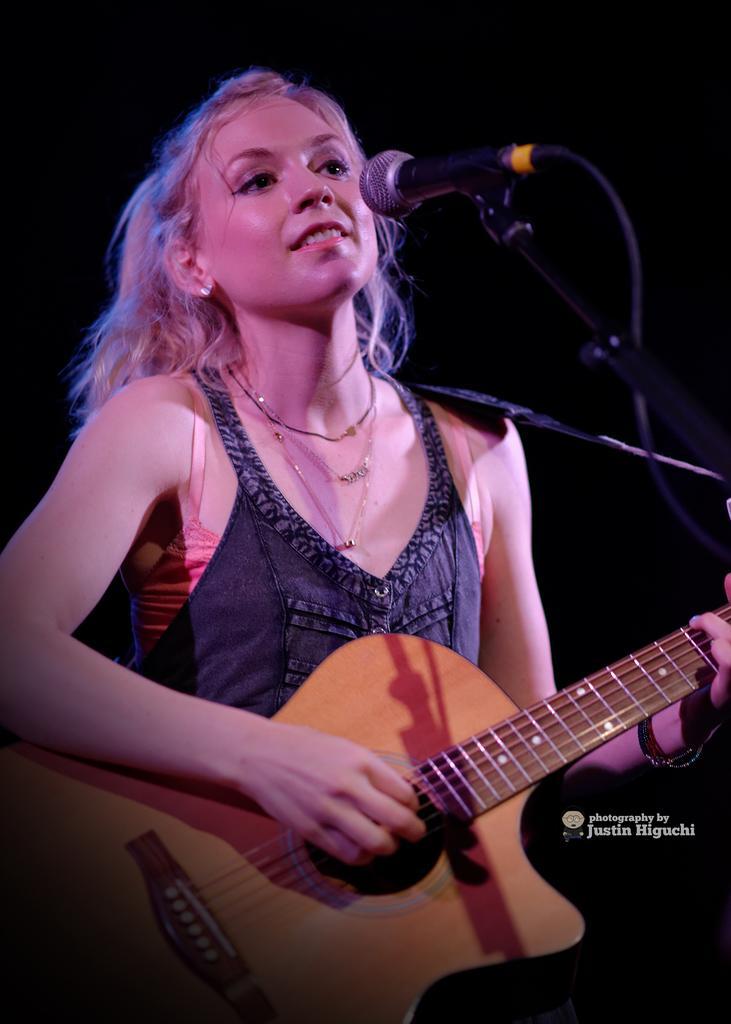Describe this image in one or two sentences. In this image i can see a woman holding a guitar and smiling there is a micro phone in front of the woman. 